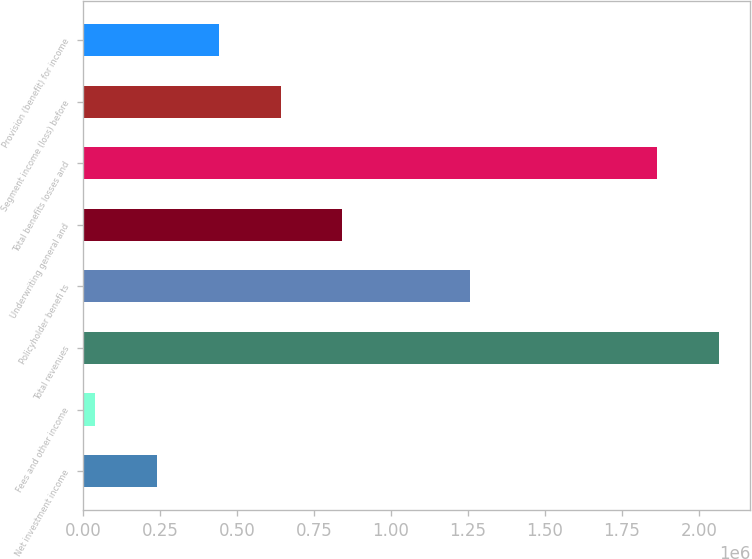Convert chart. <chart><loc_0><loc_0><loc_500><loc_500><bar_chart><fcel>Net investment income<fcel>Fees and other income<fcel>Total revenues<fcel>Policyholder benefi ts<fcel>Underwriting general and<fcel>Total benefits losses and<fcel>Segment income (loss) before<fcel>Provision (benefit) for income<nl><fcel>239859<fcel>38917<fcel>2.06373e+06<fcel>1.25819e+06<fcel>842685<fcel>1.86279e+06<fcel>641743<fcel>440801<nl></chart> 